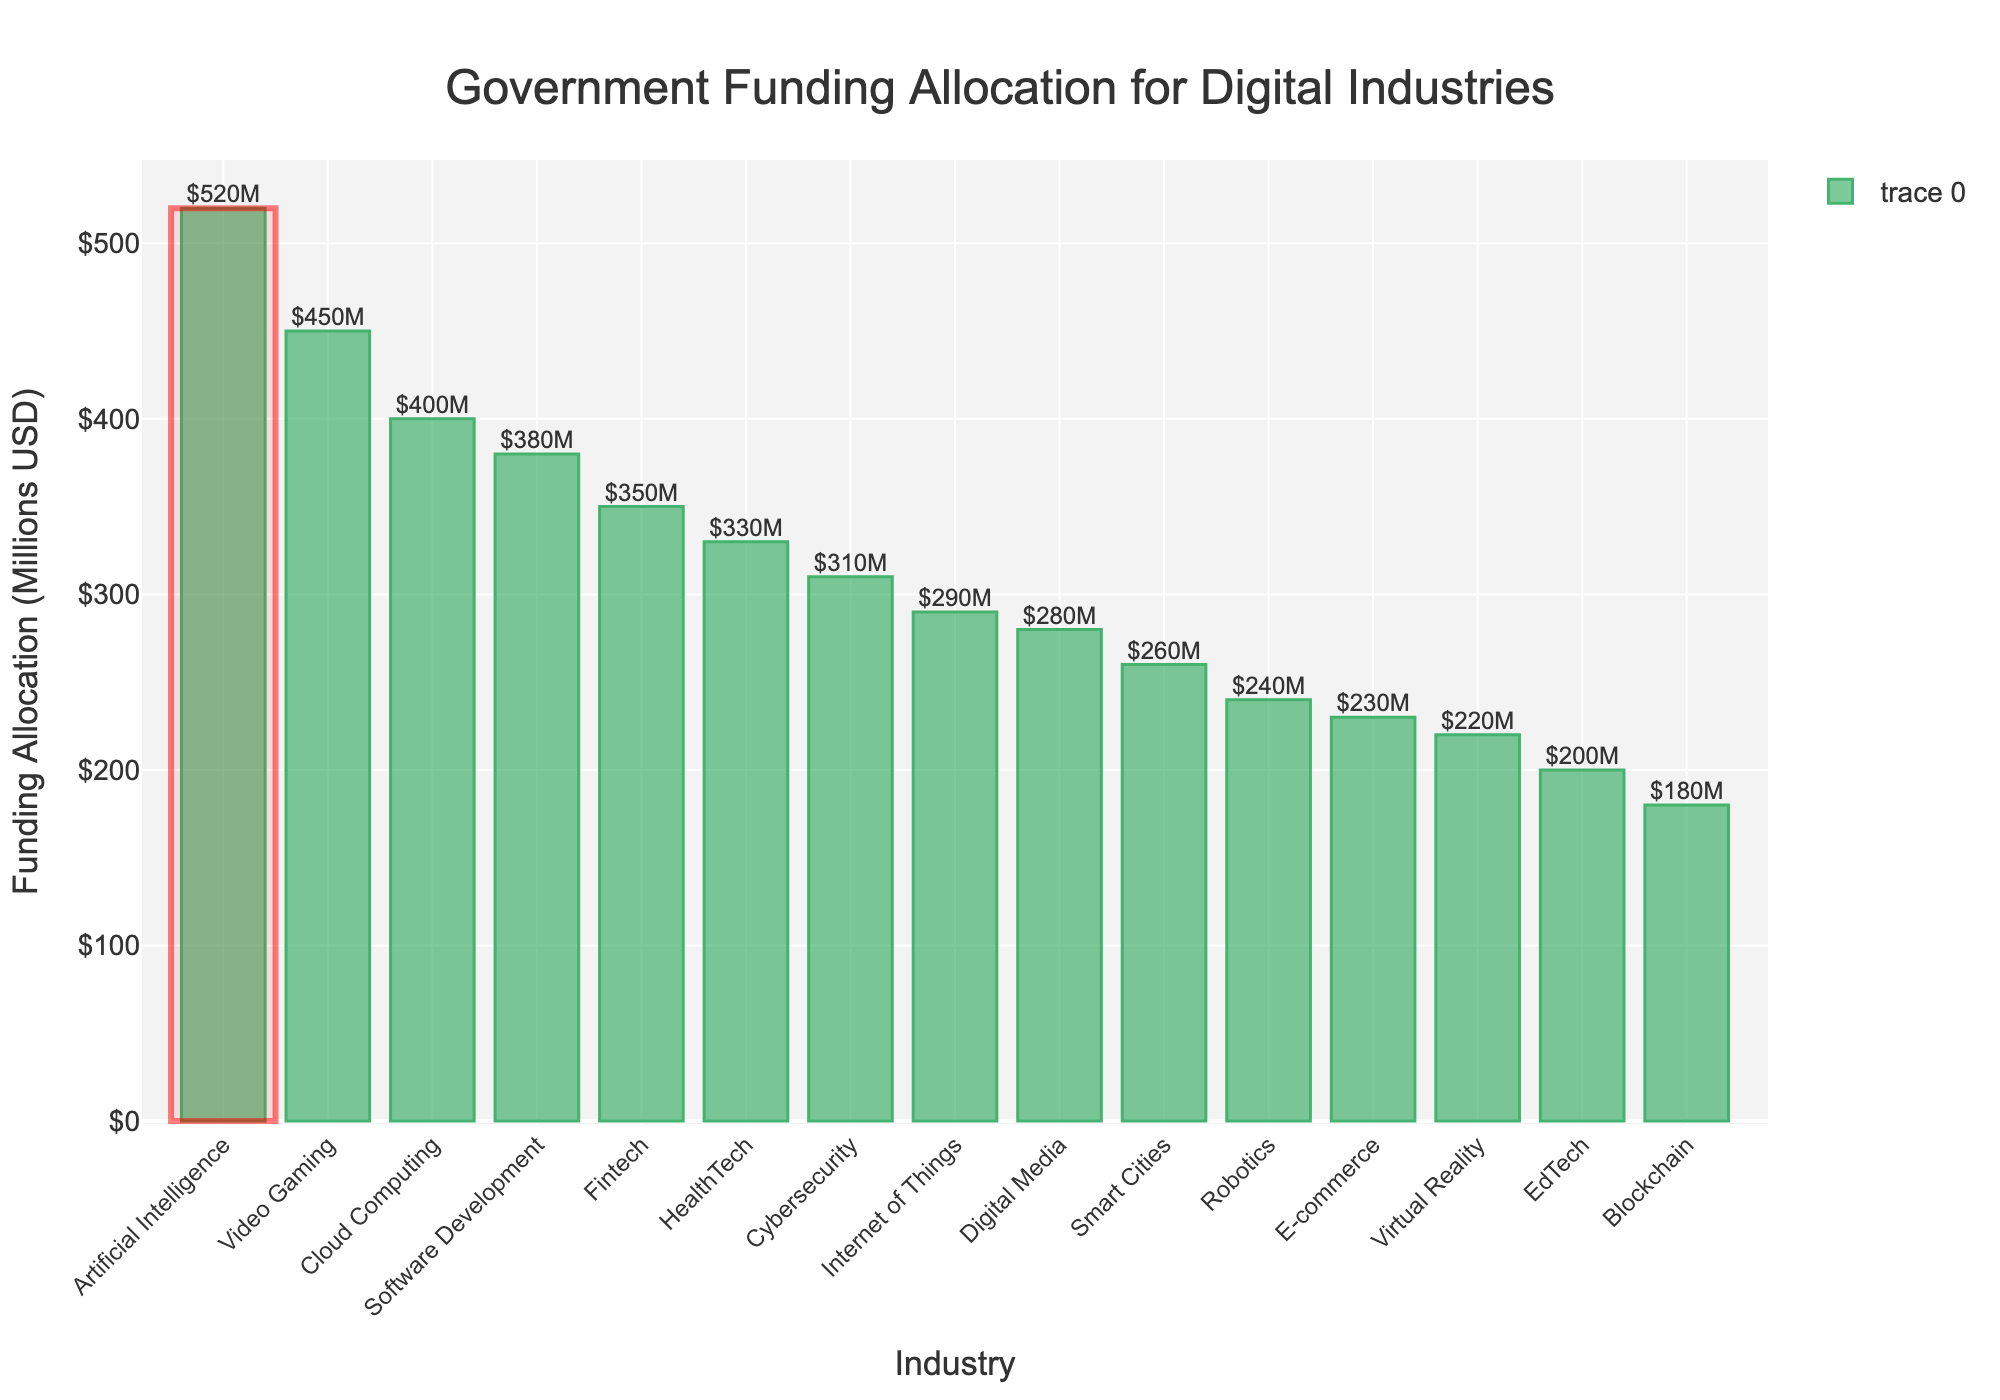Which industry received the highest government funding allocation? The plot shows that the highest bar corresponds to the "Artificial Intelligence" industry.
Answer: Artificial Intelligence How much more funding did Video Gaming receive compared to Blockchain? The funding for Video Gaming is $450M and for Blockchain is $180M. The difference is $450M - $180M.
Answer: $270M What is the total funding allocated to Digital Media and E-commerce combined? The funding for Digital Media is $280M and for E-commerce is $230M. Summing these gives $280M + $230M.
Answer: $510M Which industry received less funding: Virtual Reality or Smart Cities? The plot shows that the bar for Virtual Reality is shorter than the bar for Smart Cities. Virtual Reality received less funding.
Answer: Virtual Reality What is the average funding allocation of the Cybersecurity, IoT, and HealthTech industries? The funding allocations are $310M, $290M, and $330M respectively. The average is calculated as ($310M + $290M + $330M) / 3.
Answer: $310M Which industry received more government funding: Fintech or EdTech? By comparing the bar heights, Fintech received $350M, whereas EdTech received $200M. Fintech received more funding.
Answer: Fintech How much is the total funding allocated to industries that received less than $250M each? The industries are Blockchain ($180M), Virtual Reality ($220M), and EdTech ($200M). Summing these gives $180M + $220M + $200M.
Answer: $600M What's the difference in funding between the highest and the lowest funded industries? The highest funded industry is Artificial Intelligence with $520M, and the lowest is Blockchain with $180M. The difference is $520M - $180M.
Answer: $340M Which industry has the third highest funding allocation? Looking at the sorted bars, the third highest is Video Gaming with $450M.
Answer: Video Gaming 